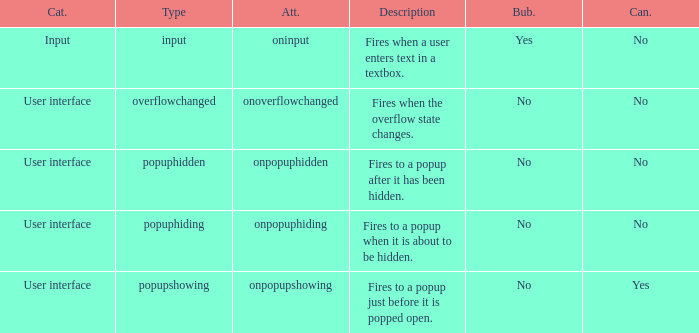What's the cancelable with bubbles being yes No. 